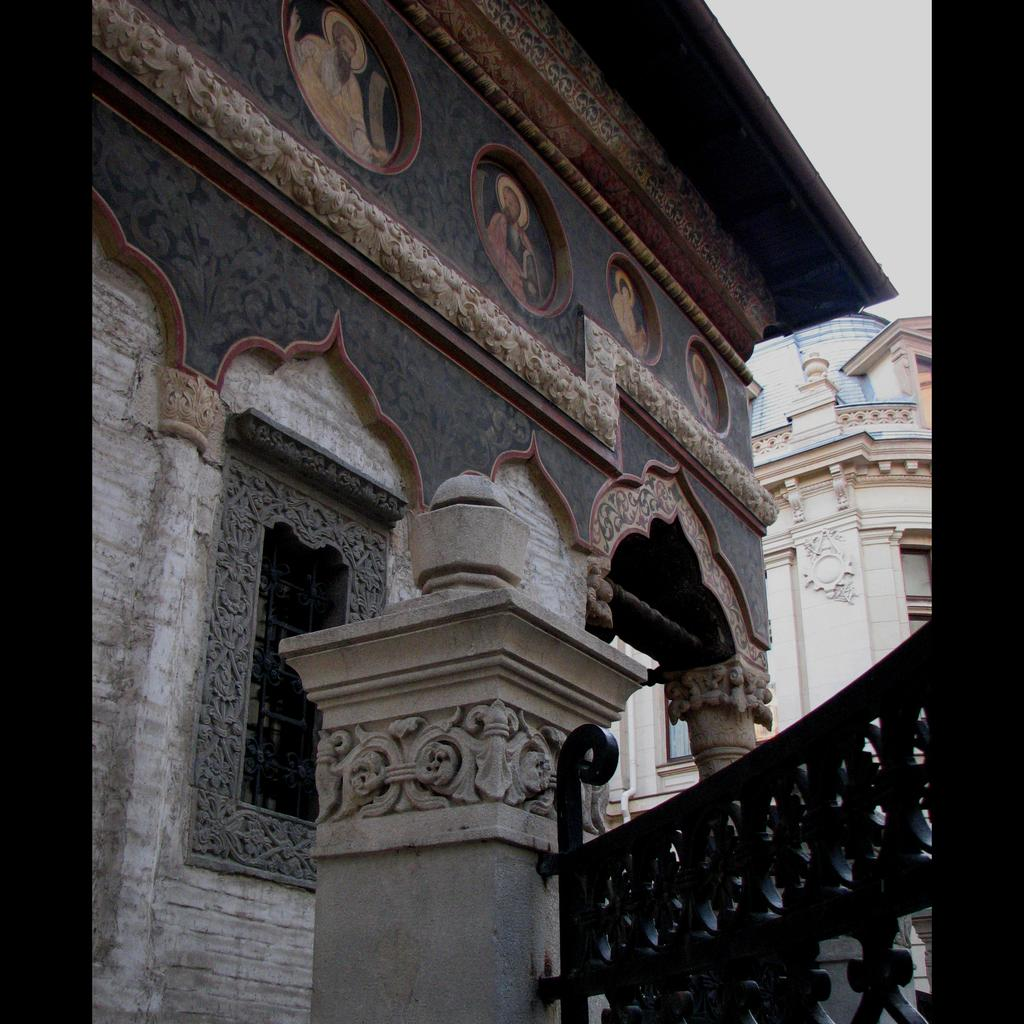What type of building is in the image? There is a stone building in the image. What can be seen on the wall of the building? There is a design on the wall of the building. Can you describe the window in the image? There is a window in the image. What is hanging on the wall inside the building? There are photos on the wall. What is located near the building in the image? There is a fence in the image. What is visible in the sky in the image? The sky is visible in the image. How many planes can be seen flying in the sky in the image? There are no planes visible in the sky in the image. Is there a robin perched on the fence in the image? There is no robin present in the image. 